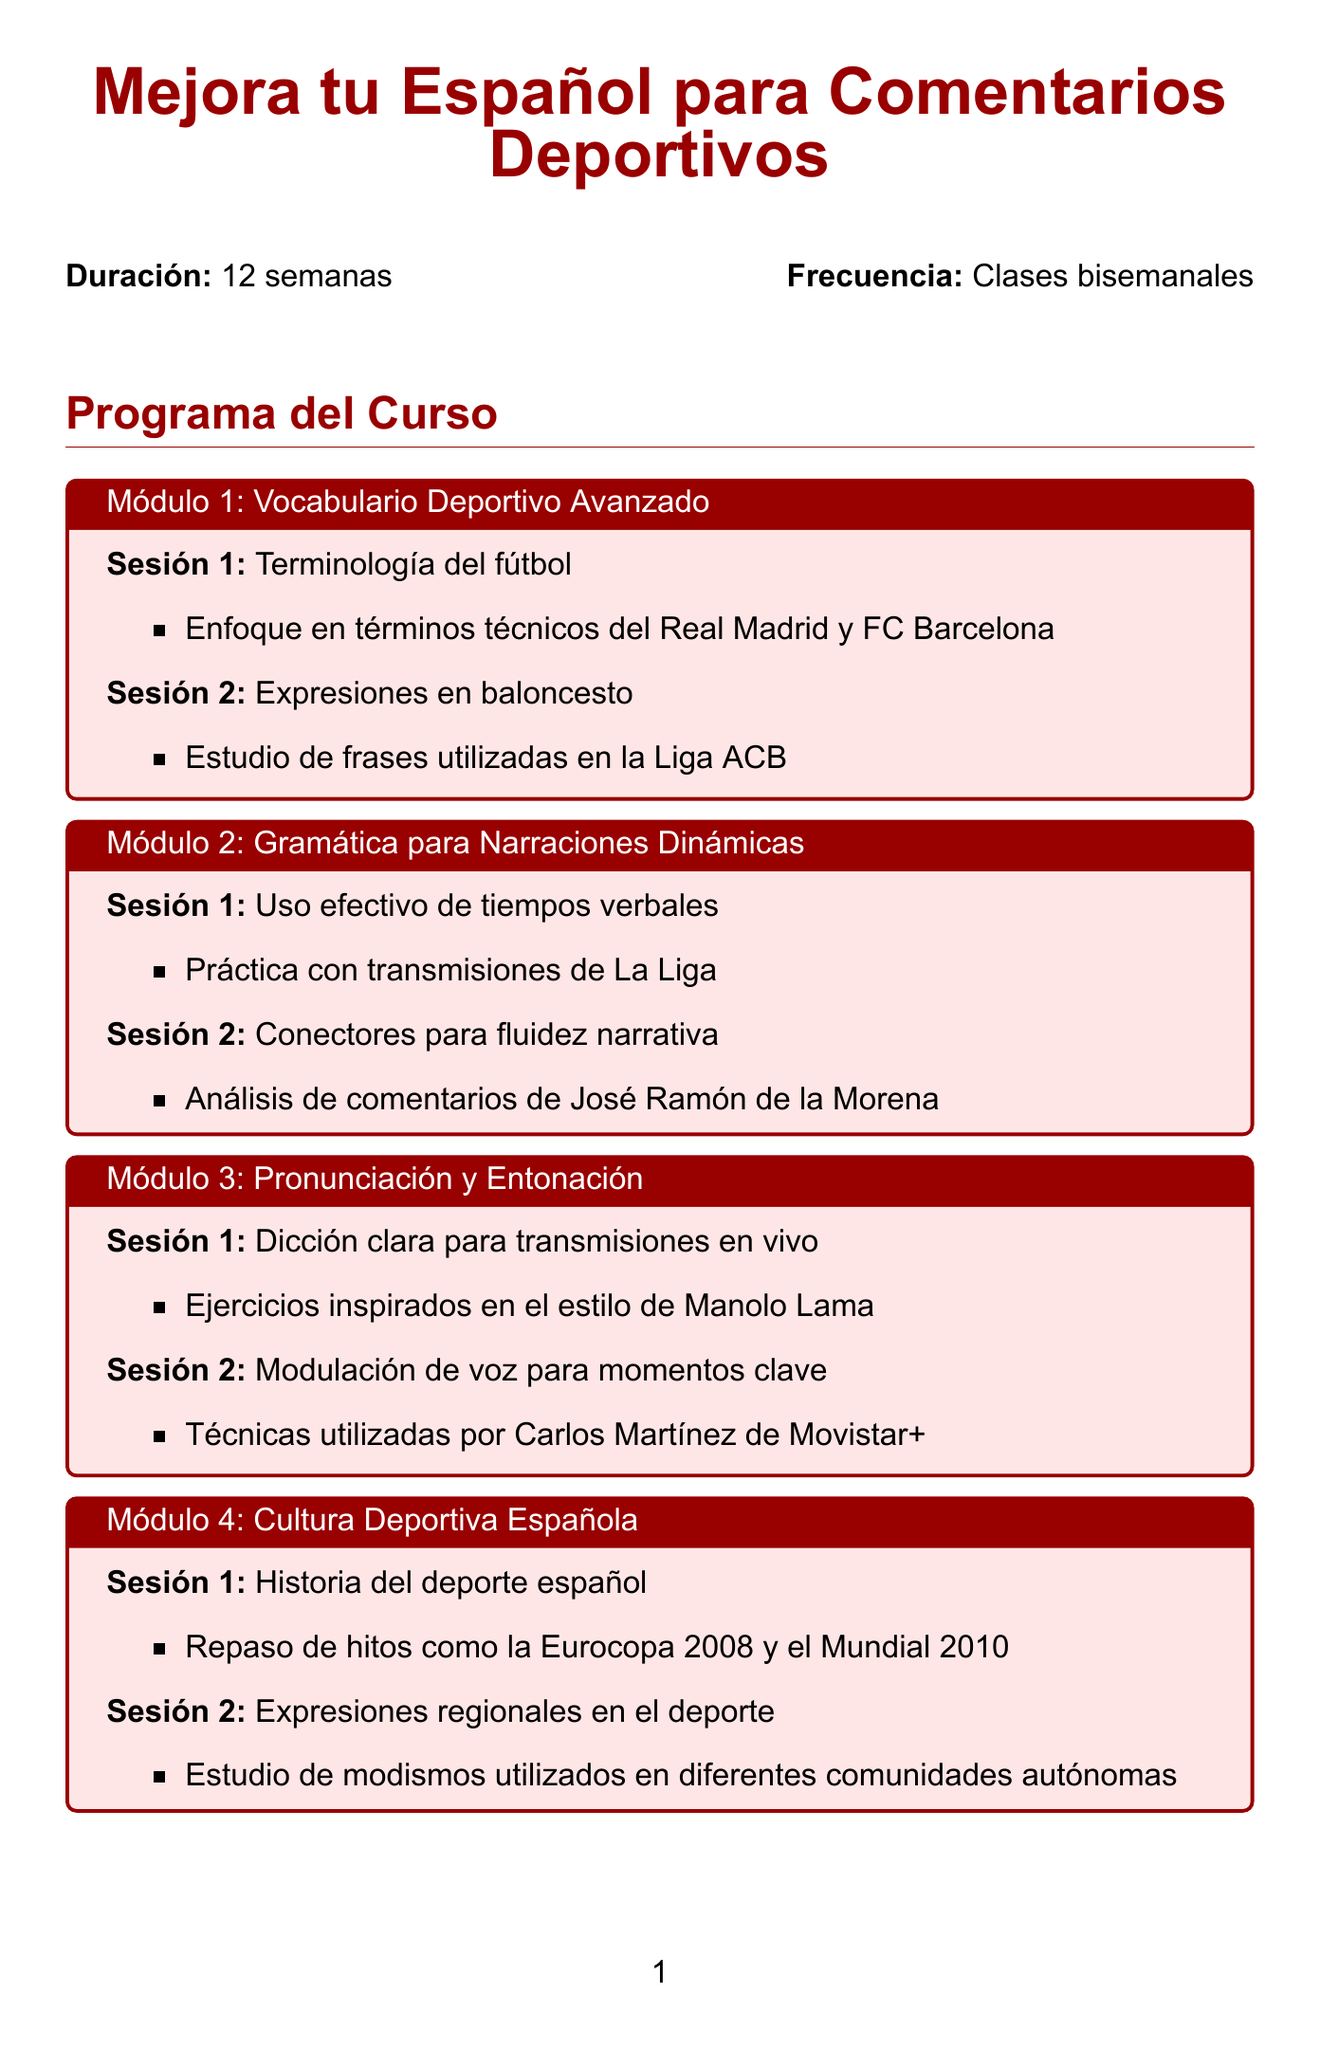¿Qué es el título del curso? El título del curso es "Mejora tu Español para Comentarios Deportivos".
Answer: Mejora tu Español para Comentarios Deportivos ¿Cuál es la duración del curso? La duración del curso es mencionada en el documento como 12 semanas.
Answer: 12 semanas ¿Qué tipo de clases se ofrecen? El documento indica que las clases son bisemanales.
Answer: Clases bisemanales ¿Cuántos módulos hay en el curso? Se enumeran seis módulos en el documento.
Answer: 6 ¿Qué tema se aborda en la sesión sobre "Terminología del fútbol"? La sesión se centra en términos técnicos del Real Madrid y FC Barcelona.
Answer: Términos técnicos del Real Madrid y FC Barcelona ¿Cuál es un recurso adicional mencionado en el documento? Se menciona "Carrusel Deportivo de la Cadena SER" como recurso adicional.
Answer: Carrusel Deportivo de la Cadena SER ¿Qué se evaluará durante la evaluación final? Se evaluará el uso apropiado del vocabulario como uno de los criterios.
Answer: Uso apropiado del vocabulario ¿Cuánto tiempo durará la evaluación final? El documento especifica que la evaluación final durará 90 minutos.
Answer: 90 minutos ¿Qué sesión trata sobre "Modulación de voz para momentos clave"? Esta sesión se enfoca en técnicas utilizadas por Carlos Martínez de Movistar+.
Answer: Técnicas utilizadas por Carlos Martínez de Movistar+ 